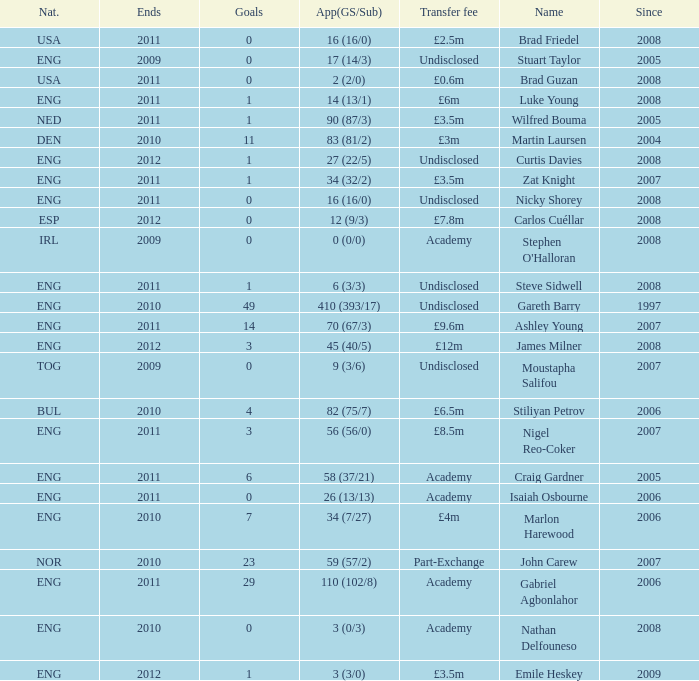When the transfer fee is £8.5m, what is the total ends? 2011.0. 